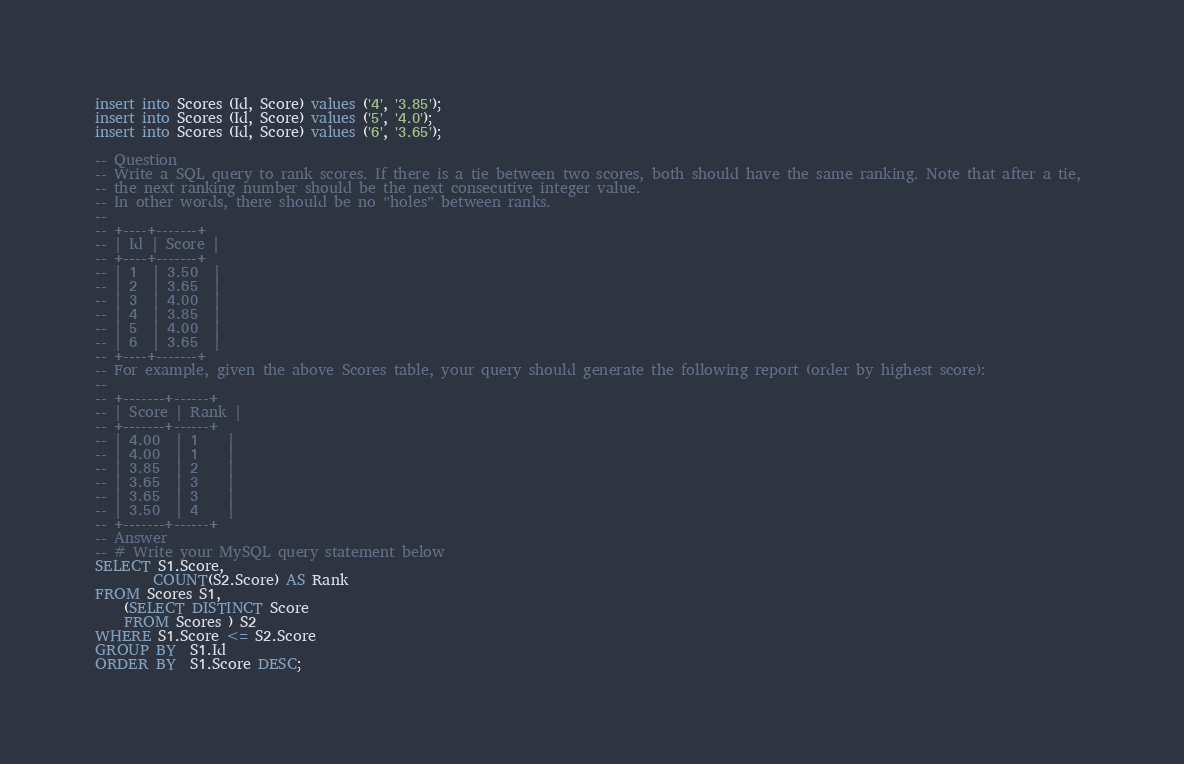Convert code to text. <code><loc_0><loc_0><loc_500><loc_500><_SQL_>insert into Scores (Id, Score) values ('4', '3.85');
insert into Scores (Id, Score) values ('5', '4.0');
insert into Scores (Id, Score) values ('6', '3.65');

-- Question
-- Write a SQL query to rank scores. If there is a tie between two scores, both should have the same ranking. Note that after a tie, 
-- the next ranking number should be the next consecutive integer value.
-- In other words, there should be no "holes" between ranks.
--
-- +----+-------+
-- | Id | Score |
-- +----+-------+
-- | 1  | 3.50  |
-- | 2  | 3.65  |
-- | 3  | 4.00  |
-- | 4  | 3.85  |
-- | 5  | 4.00  |
-- | 6  | 3.65  |
-- +----+-------+
-- For example, given the above Scores table, your query should generate the following report (order by highest score):
--
-- +-------+------+
-- | Score | Rank |
-- +-------+------+
-- | 4.00  | 1    |
-- | 4.00  | 1    |
-- | 3.85  | 2    |
-- | 3.65  | 3    |
-- | 3.65  | 3    |
-- | 3.50  | 4    |
-- +-------+------+
-- Answer
-- # Write your MySQL query statement below
SELECT S1.Score,
        COUNT(S2.Score) AS Rank
FROM Scores S1,
    (SELECT DISTINCT Score
    FROM Scores ) S2
WHERE S1.Score <= S2.Score
GROUP BY  S1.Id
ORDER BY  S1.Score DESC;</code> 